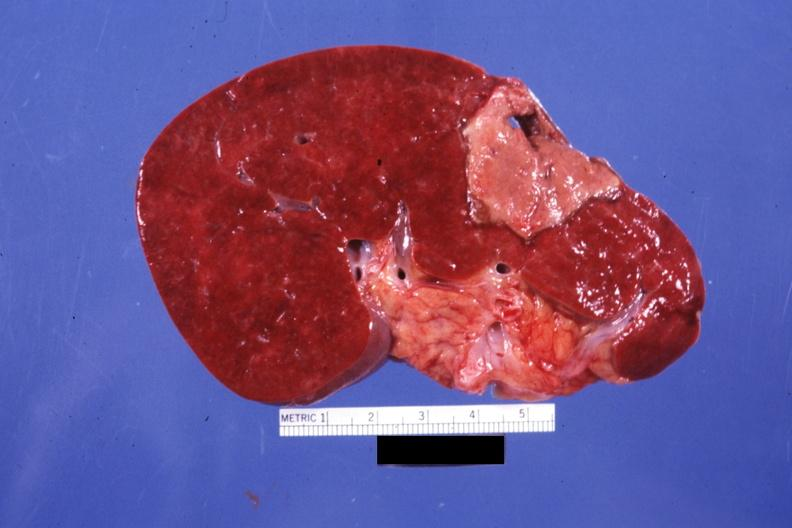s spleen present?
Answer the question using a single word or phrase. Yes 